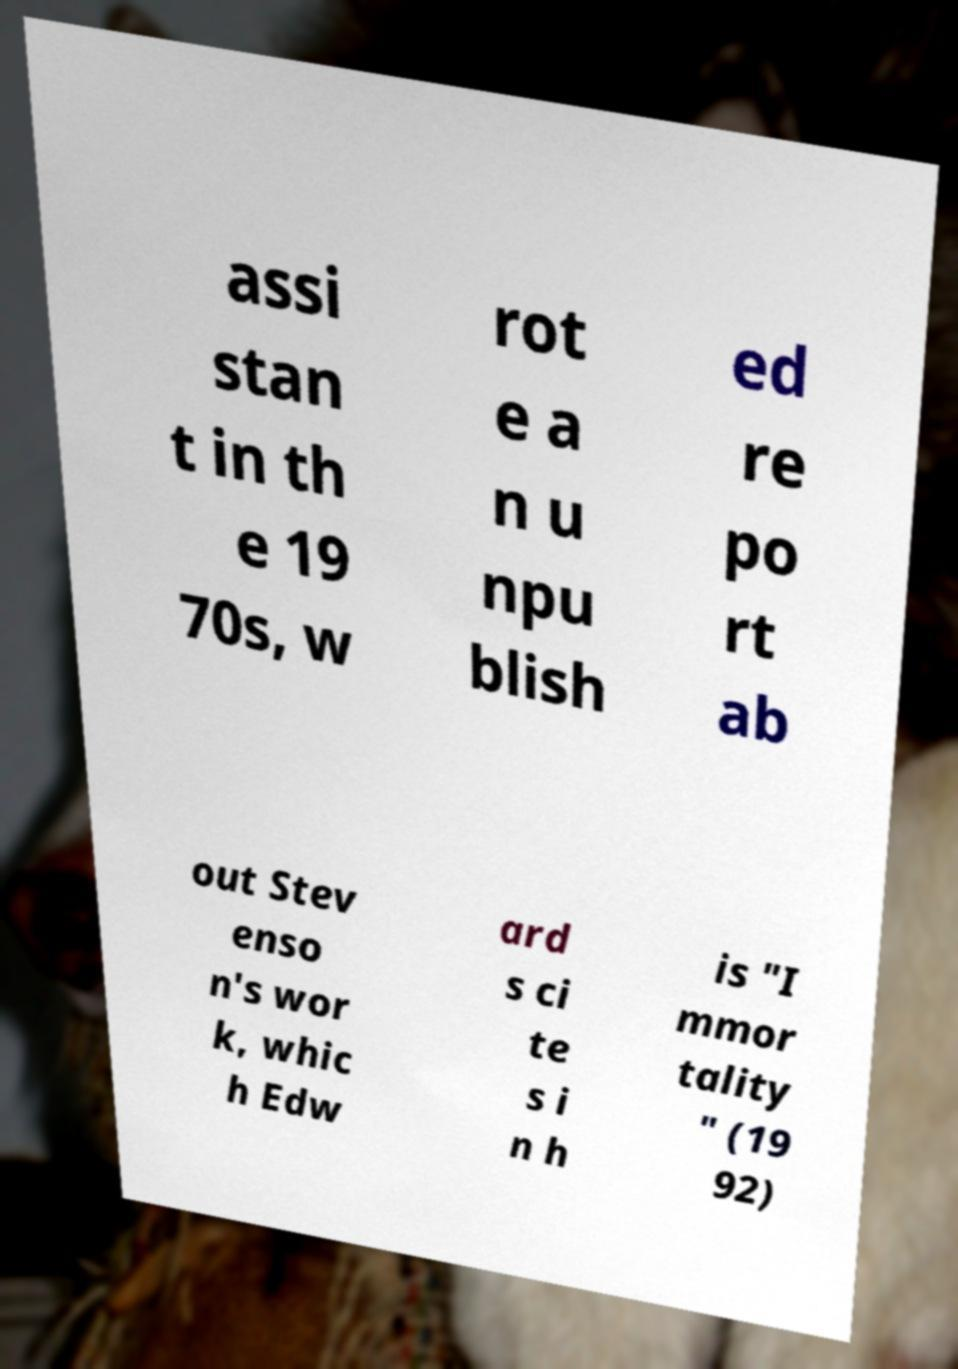There's text embedded in this image that I need extracted. Can you transcribe it verbatim? assi stan t in th e 19 70s, w rot e a n u npu blish ed re po rt ab out Stev enso n's wor k, whic h Edw ard s ci te s i n h is "I mmor tality " (19 92) 